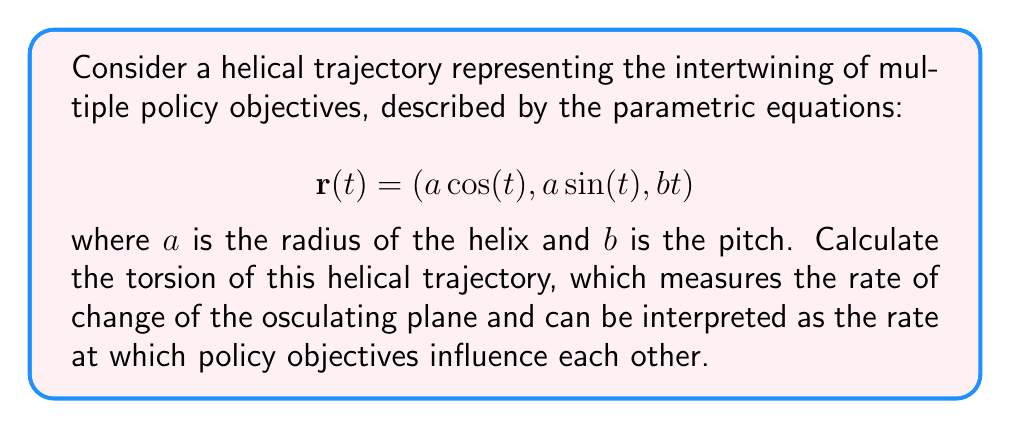Show me your answer to this math problem. To calculate the torsion of the helical trajectory, we'll follow these steps:

1) First, we need to calculate the first, second, and third derivatives of $\mathbf{r}(t)$:

   $\mathbf{r}'(t) = (-a \sin(t), a \cos(t), b)$
   $\mathbf{r}''(t) = (-a \cos(t), -a \sin(t), 0)$
   $\mathbf{r}'''(t) = (a \sin(t), -a \cos(t), 0)$

2) The torsion $\tau$ is given by the formula:

   $$\tau = \frac{(\mathbf{r}' \times \mathbf{r}'') \cdot \mathbf{r}'''}{|\mathbf{r}' \times \mathbf{r}''|^2}$$

3) Let's calculate $\mathbf{r}' \times \mathbf{r}''$:

   $\mathbf{r}' \times \mathbf{r}'' = (ab \sin(t), -ab \cos(t), a^2)$

4) Now, $(\mathbf{r}' \times \mathbf{r}'') \cdot \mathbf{r}'''$:

   $(\mathbf{r}' \times \mathbf{r}'') \cdot \mathbf{r}''' = (ab \sin(t))(a \sin(t)) + (-ab \cos(t))(-a \cos(t)) + (a^2)(0) = a^2b$

5) Calculate $|\mathbf{r}' \times \mathbf{r}''|^2$:

   $|\mathbf{r}' \times \mathbf{r}''|^2 = (ab \sin(t))^2 + (-ab \cos(t))^2 + (a^2)^2 = a^2b^2 + a^4$

6) Finally, we can calculate the torsion:

   $$\tau = \frac{a^2b}{a^2b^2 + a^4} = \frac{b}{a^2 + b^2}$$

This constant torsion indicates that the rate at which policy objectives influence each other remains steady along the helical trajectory.
Answer: $\tau = \frac{b}{a^2 + b^2}$ 